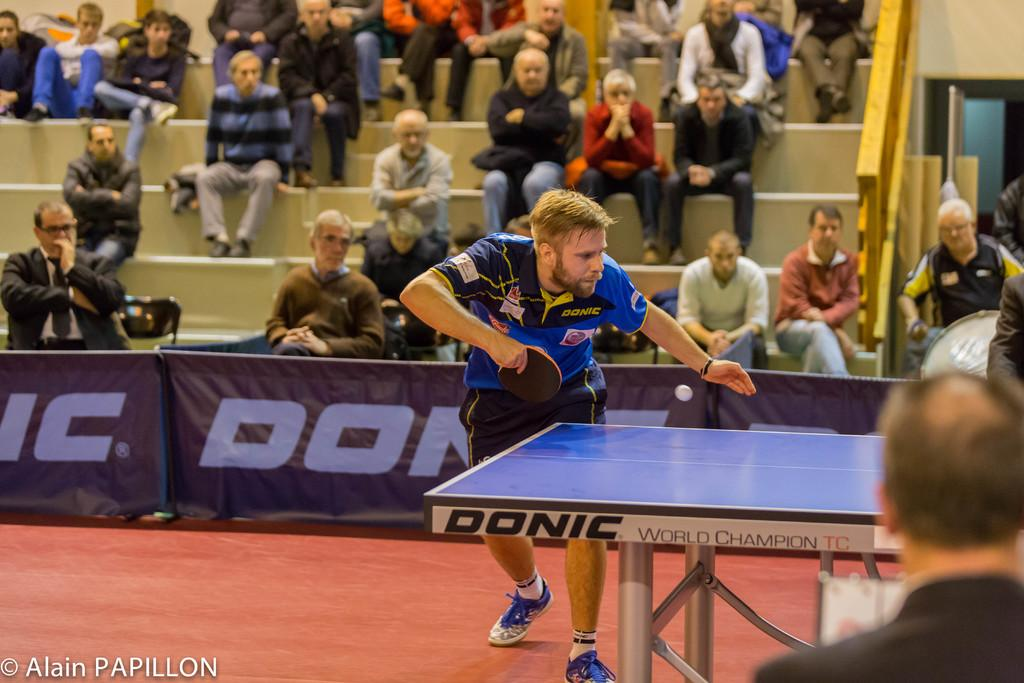What activity is the person in the image engaged in? There is a person playing table tennis in the image. Where is the table tennis player located? The person is in a court. Are there any other people present in the image? Yes, there are people sitting behind the table tennis player. What are the people behind the player doing? The people are watching the sport. Can you see a boat in the image? No, there is no boat present in the image. Is there a lamp illuminating the table tennis court? No, there is no lamp visible in the image. 